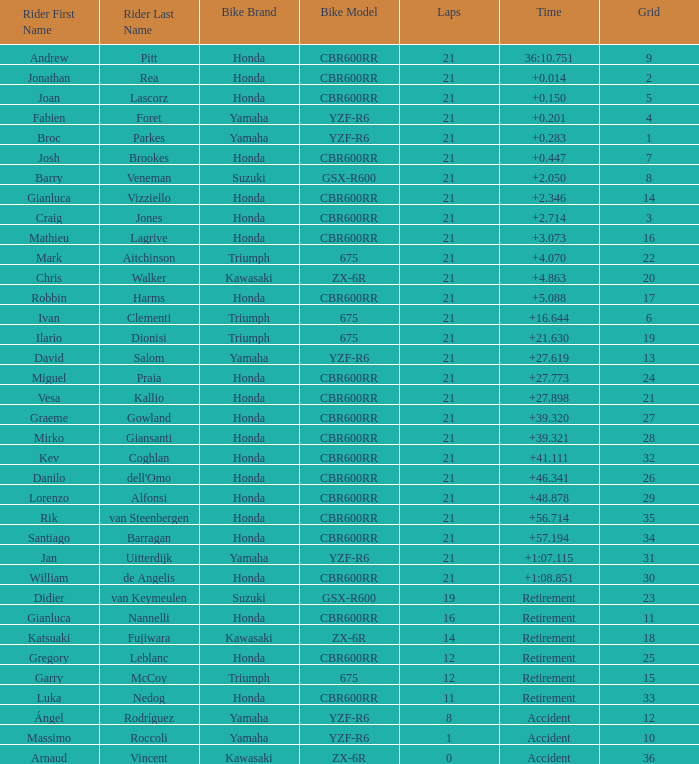What is the most number of laps run by Ilario Dionisi? 21.0. 